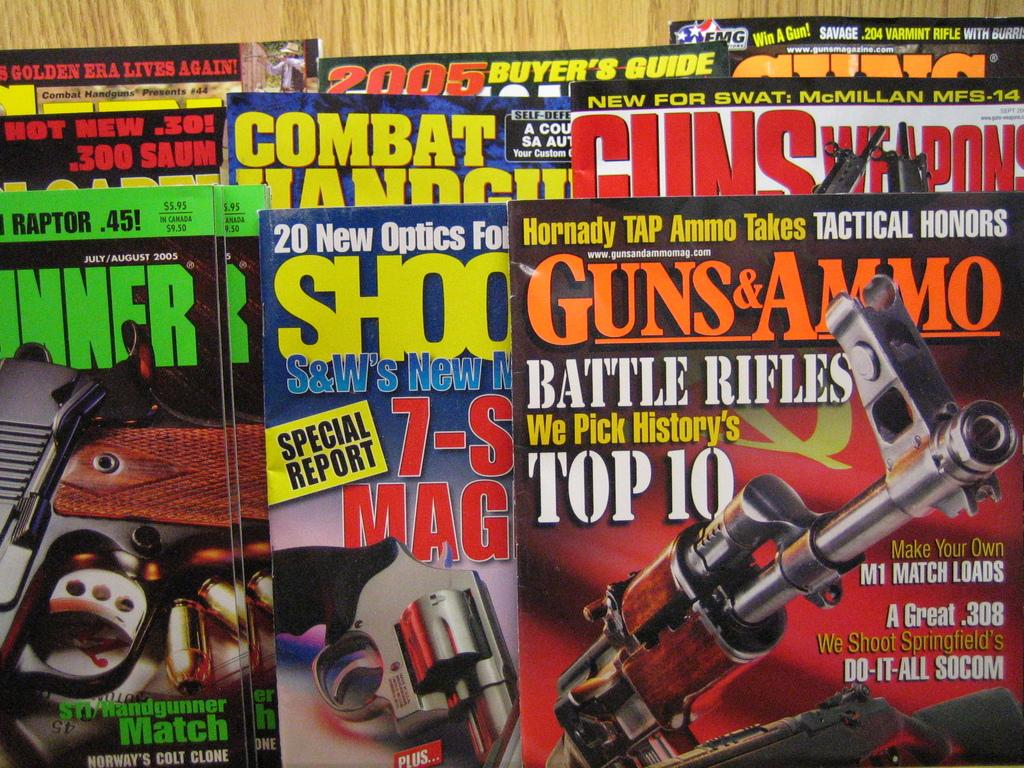<image>
Describe the image concisely. some magazines that have guns & ammo written on it 